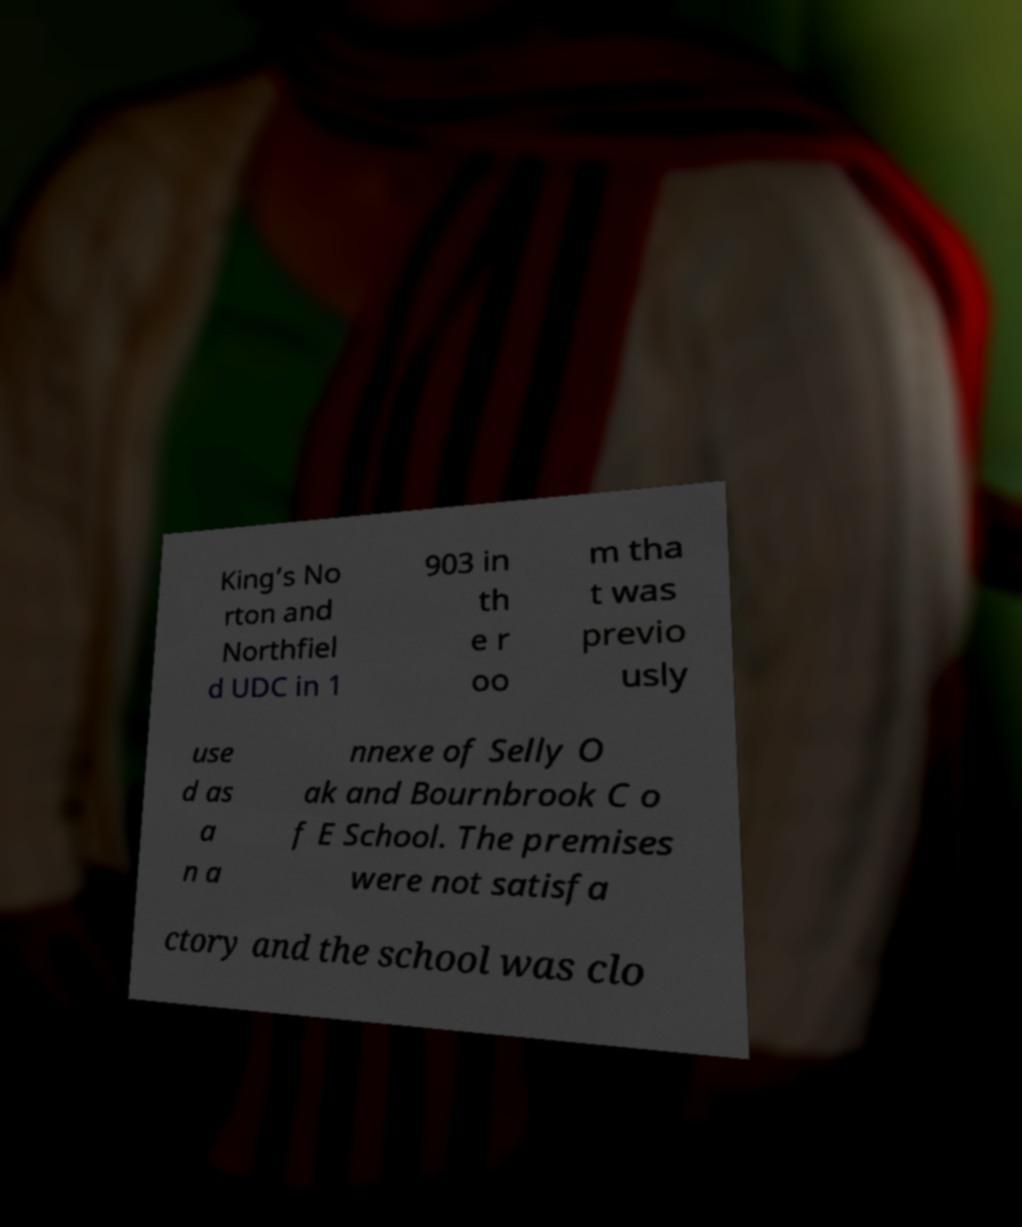Can you accurately transcribe the text from the provided image for me? King’s No rton and Northfiel d UDC in 1 903 in th e r oo m tha t was previo usly use d as a n a nnexe of Selly O ak and Bournbrook C o f E School. The premises were not satisfa ctory and the school was clo 